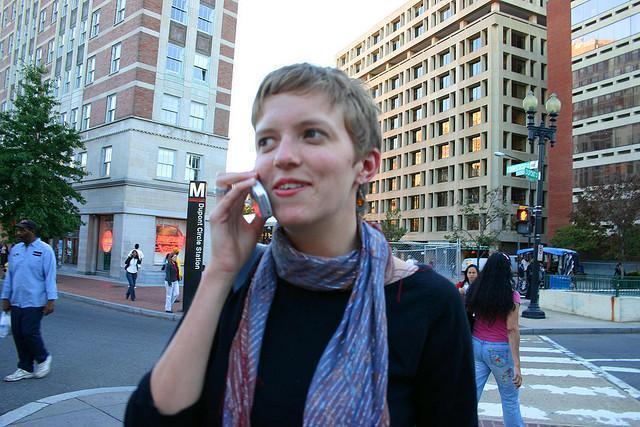How many people are in the picture?
Give a very brief answer. 3. 